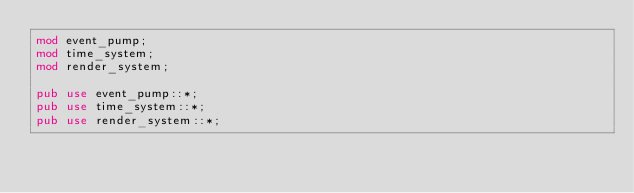Convert code to text. <code><loc_0><loc_0><loc_500><loc_500><_Rust_>mod event_pump;
mod time_system;
mod render_system;

pub use event_pump::*;
pub use time_system::*;
pub use render_system::*;</code> 